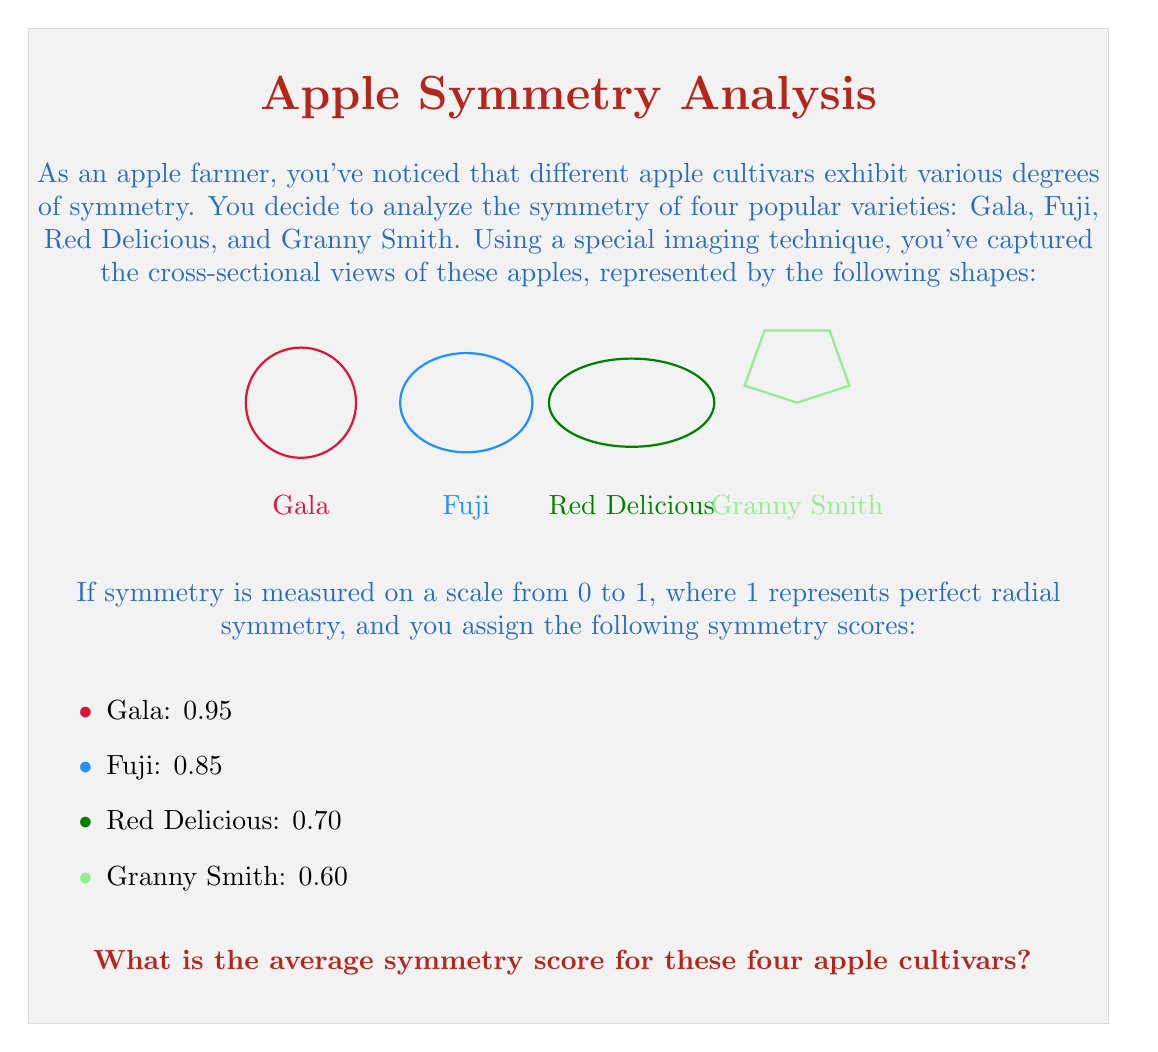Can you answer this question? To find the average symmetry score, we need to follow these steps:

1. Identify the symmetry scores for each apple cultivar:
   Gala: 0.95
   Fuji: 0.85
   Red Delicious: 0.70
   Granny Smith: 0.60

2. Sum up all the symmetry scores:
   $$0.95 + 0.85 + 0.70 + 0.60 = 3.10$$

3. Count the total number of apple cultivars:
   There are 4 cultivars in total.

4. Calculate the average by dividing the sum of scores by the number of cultivars:
   $$\text{Average} = \frac{\text{Sum of scores}}{\text{Number of cultivars}} = \frac{3.10}{4} = 0.775$$

Therefore, the average symmetry score for these four apple cultivars is 0.775.
Answer: 0.775 